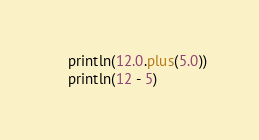Convert code to text. <code><loc_0><loc_0><loc_500><loc_500><_Kotlin_>    println(12.0.plus(5.0))
    println(12 - 5)</code> 